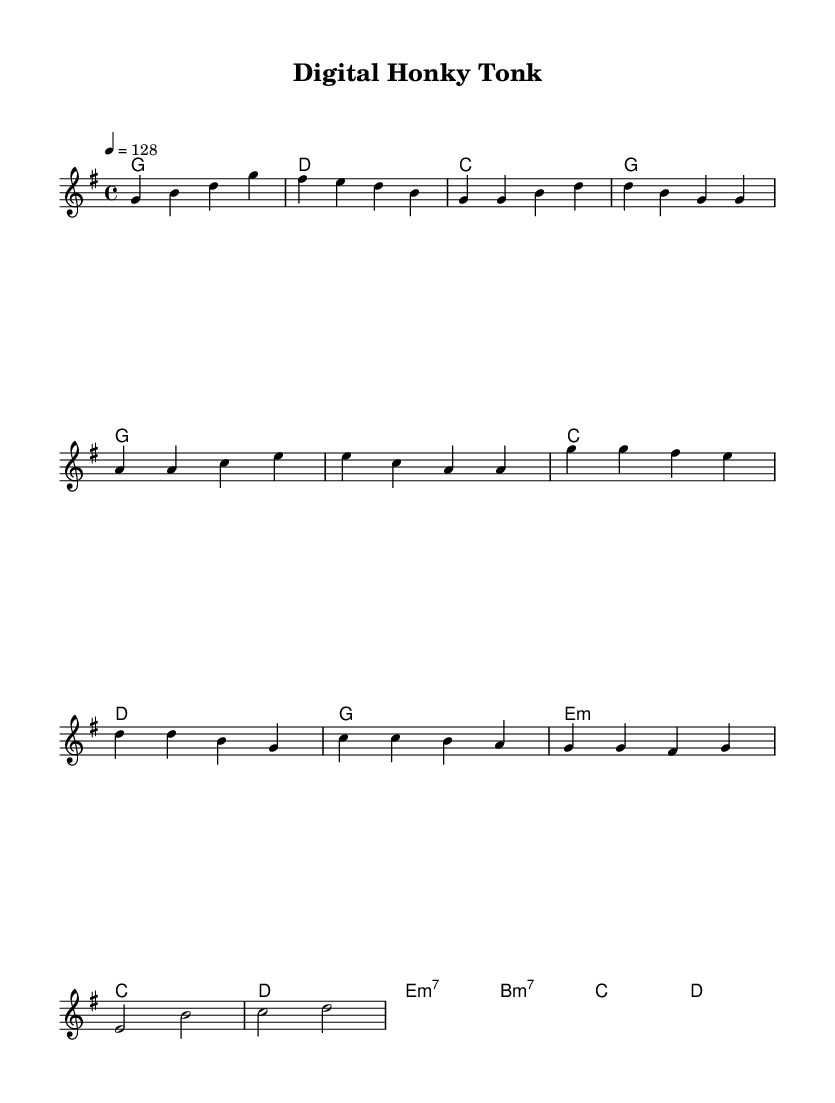What is the key signature of this music? The key signature is G major, which has one sharp (F#). It can be identified from the beginning of the score, where the key is notated and corresponds to the notes used throughout the piece.
Answer: G major What is the time signature of the piece? The time signature is 4/4, which means there are four beats in each measure and a quarter note receives one beat. This can be seen at the start of the score, where the time signature is indicated.
Answer: 4/4 What is the tempo marking for this music? The tempo marking is 128 beats per minute, which specifies how fast the music should be played. This is provided at the beginning under the tempo notation.
Answer: 128 How many measures are in the chorus? There are four measures in the chorus, which can be counted by identifying the section marked as "Chorus" and counting the corresponding measures beneath it.
Answer: 4 Which chord is played during the bridge? The chord played during the bridge is E minor 7, which is indicated in the harmonies section of the sheet music. This is clarified by the chord symbol written directly above the measures in that section.
Answer: E minor 7 What type of instruments are primarily featured in this piece? The primary instruments featured are traditional country instruments alongside electronic elements. This fusion can be inferred from the description of the piece and typical characteristics of the Country Rock genre, although specific instrument notation isn't shown on the score itself.
Answer: Country instruments and electronics 